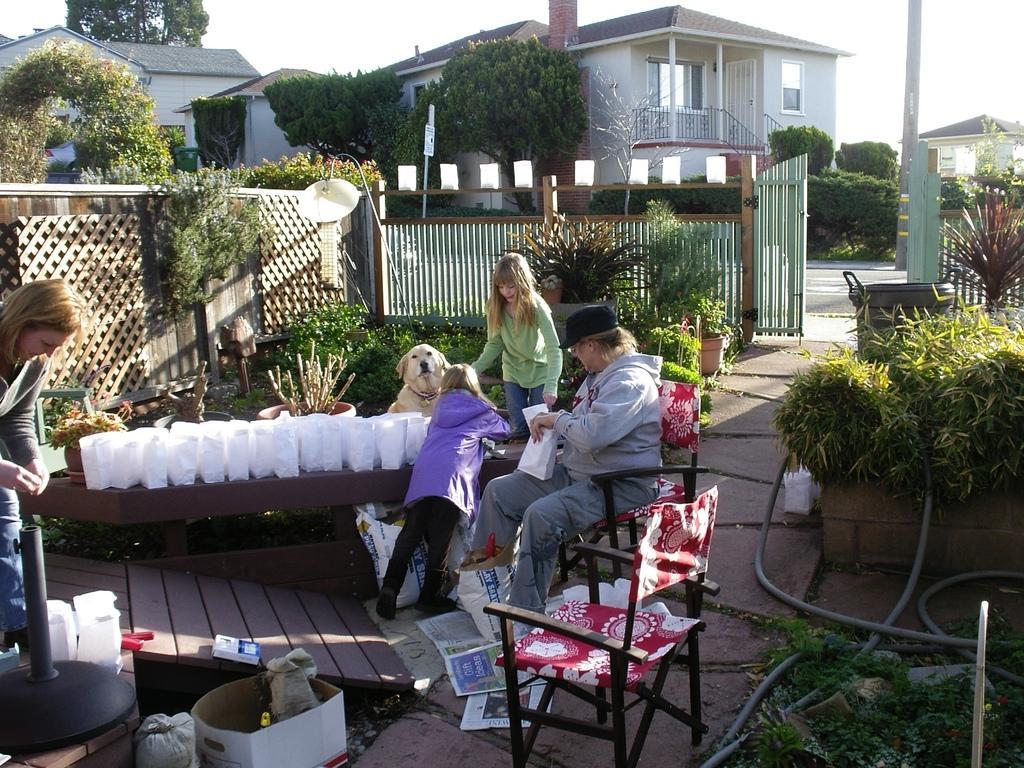Please provide a concise description of this image. As we can see in the image there is a sky, building, brown color roof, trees, plants, wire, white color dog, grass, few people here and there. There are chairs, box, newspaper and there is a lamp over here. 